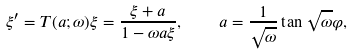<formula> <loc_0><loc_0><loc_500><loc_500>\xi ^ { \prime } = T ( a ; \omega ) \xi = \frac { \xi + a } { 1 - \omega { a \xi } } , \quad a = \frac { 1 } { \sqrt { \omega } } \tan \sqrt { \omega } \varphi ,</formula> 